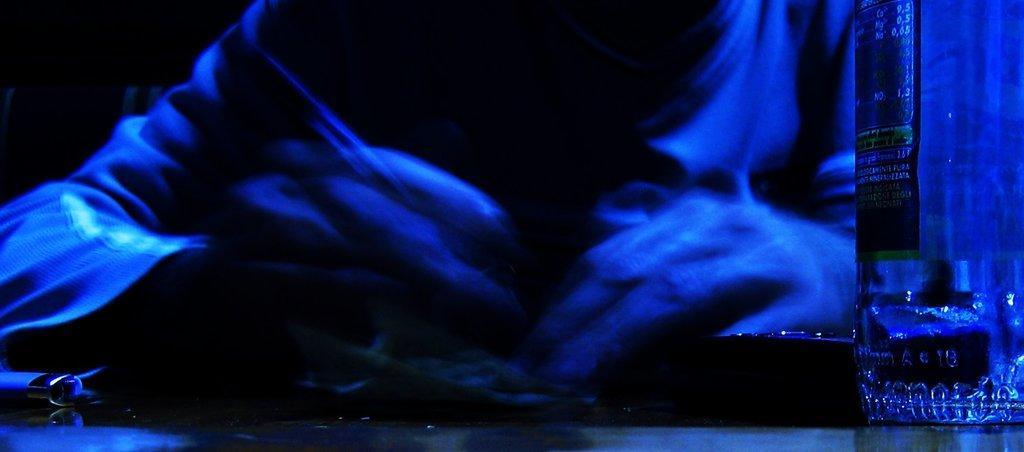In one or two sentences, can you explain what this image depicts? In this image I can see the person holding something. In-front of the person I can see the bottle and the image is in blue and black color. 